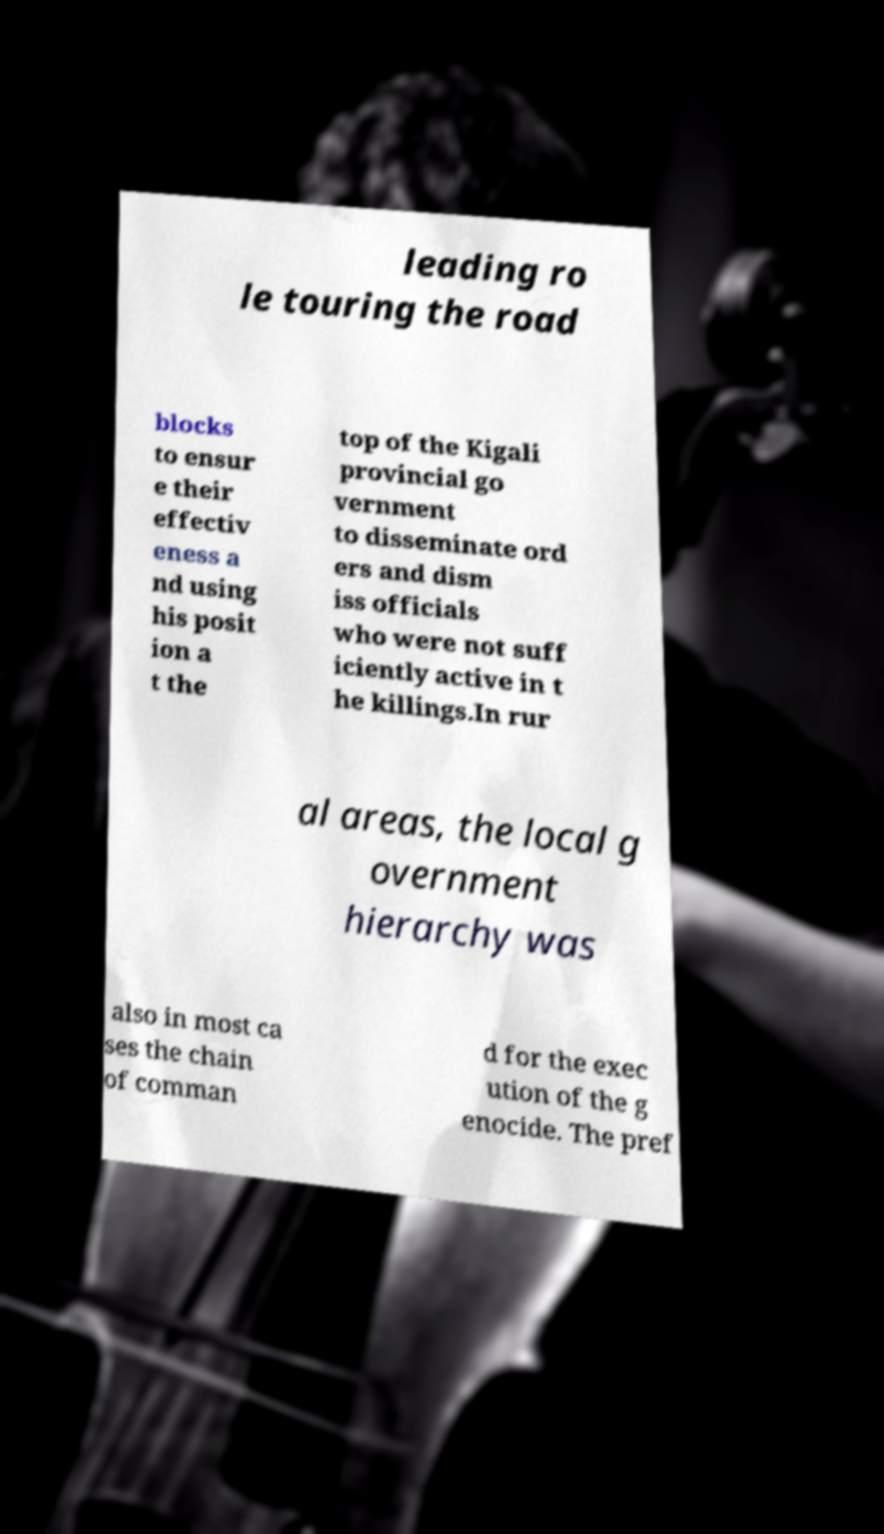Could you extract and type out the text from this image? leading ro le touring the road blocks to ensur e their effectiv eness a nd using his posit ion a t the top of the Kigali provincial go vernment to disseminate ord ers and dism iss officials who were not suff iciently active in t he killings.In rur al areas, the local g overnment hierarchy was also in most ca ses the chain of comman d for the exec ution of the g enocide. The pref 